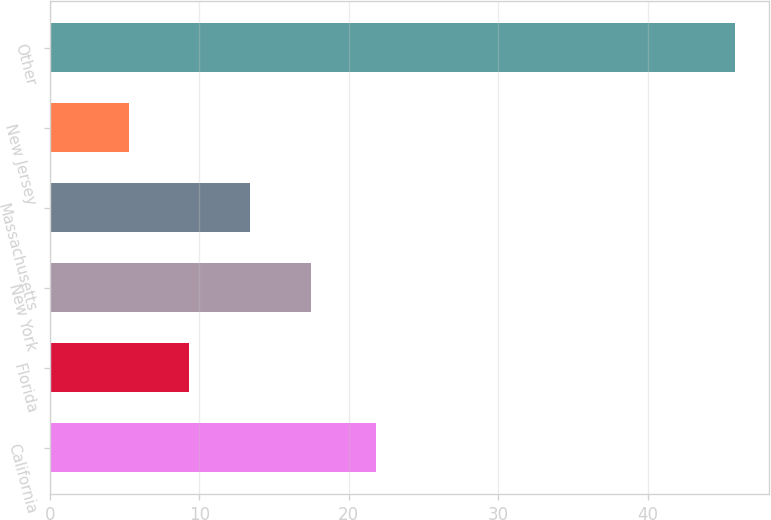Convert chart. <chart><loc_0><loc_0><loc_500><loc_500><bar_chart><fcel>California<fcel>Florida<fcel>New York<fcel>Massachusetts<fcel>New Jersey<fcel>Other<nl><fcel>21.8<fcel>9.35<fcel>17.45<fcel>13.4<fcel>5.3<fcel>45.8<nl></chart> 